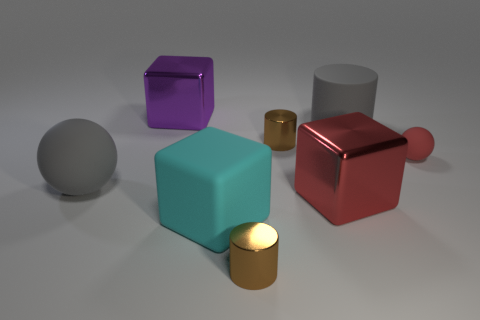There is a big cylinder that is the same color as the large sphere; what material is it?
Make the answer very short. Rubber. What number of big things are behind the tiny red matte sphere and in front of the large purple cube?
Provide a short and direct response. 1. There is a big gray object that is right of the thing on the left side of the purple cube; what is its material?
Make the answer very short. Rubber. Is there a big cyan cube made of the same material as the big gray cylinder?
Offer a very short reply. Yes. What is the material of the sphere that is the same size as the cyan cube?
Ensure brevity in your answer.  Rubber. There is a cube that is in front of the cube right of the brown cylinder that is in front of the tiny ball; what is its size?
Your answer should be compact. Large. Are there any red cubes in front of the big metallic cube in front of the small red object?
Make the answer very short. No. Is the shape of the purple object the same as the large shiny object that is in front of the large purple object?
Provide a short and direct response. Yes. What color is the ball that is left of the purple cube?
Your response must be concise. Gray. How big is the brown thing on the right side of the small brown cylinder that is in front of the large sphere?
Your answer should be compact. Small. 